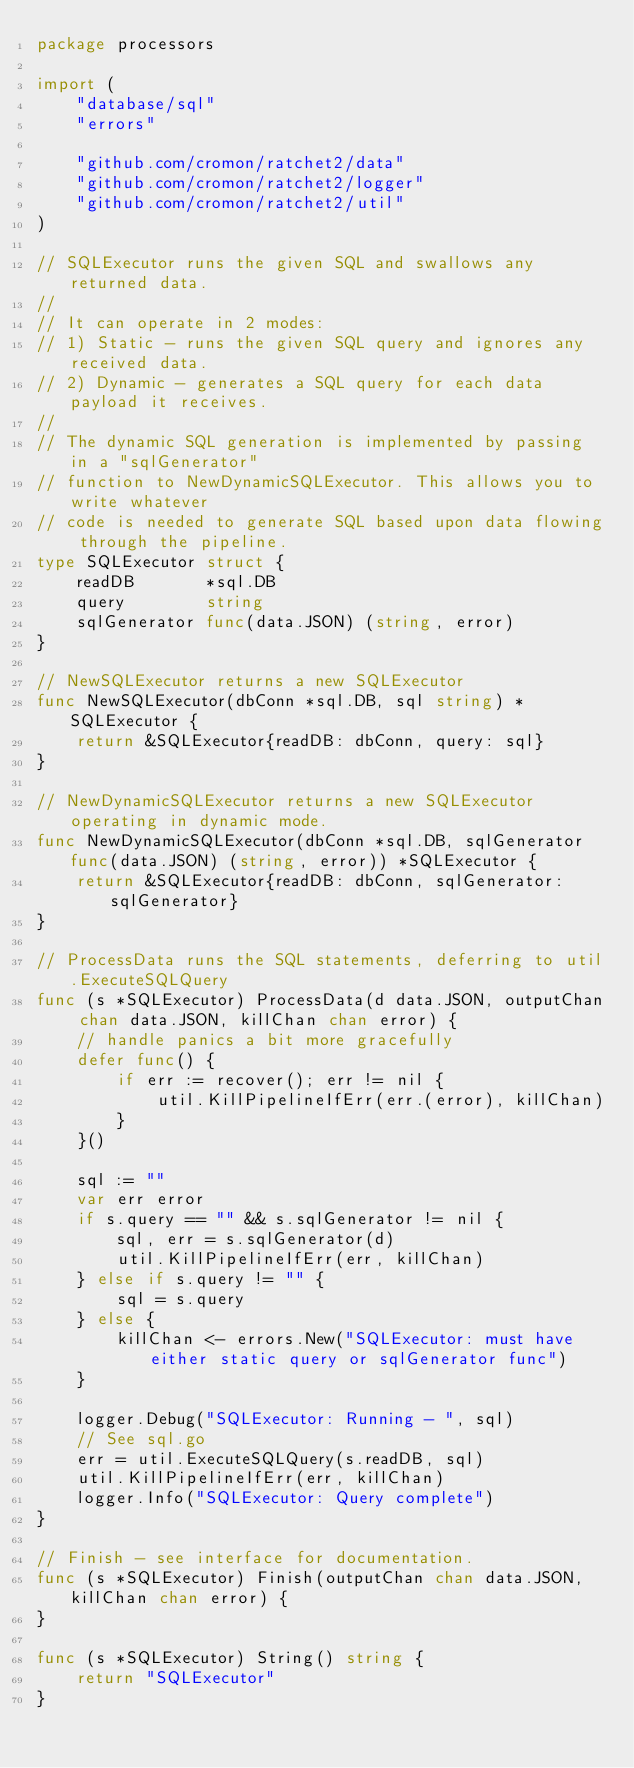Convert code to text. <code><loc_0><loc_0><loc_500><loc_500><_Go_>package processors

import (
	"database/sql"
	"errors"

	"github.com/cromon/ratchet2/data"
	"github.com/cromon/ratchet2/logger"
	"github.com/cromon/ratchet2/util"
)

// SQLExecutor runs the given SQL and swallows any returned data.
//
// It can operate in 2 modes:
// 1) Static - runs the given SQL query and ignores any received data.
// 2) Dynamic - generates a SQL query for each data payload it receives.
//
// The dynamic SQL generation is implemented by passing in a "sqlGenerator"
// function to NewDynamicSQLExecutor. This allows you to write whatever
// code is needed to generate SQL based upon data flowing through the pipeline.
type SQLExecutor struct {
	readDB       *sql.DB
	query        string
	sqlGenerator func(data.JSON) (string, error)
}

// NewSQLExecutor returns a new SQLExecutor
func NewSQLExecutor(dbConn *sql.DB, sql string) *SQLExecutor {
	return &SQLExecutor{readDB: dbConn, query: sql}
}

// NewDynamicSQLExecutor returns a new SQLExecutor operating in dynamic mode.
func NewDynamicSQLExecutor(dbConn *sql.DB, sqlGenerator func(data.JSON) (string, error)) *SQLExecutor {
	return &SQLExecutor{readDB: dbConn, sqlGenerator: sqlGenerator}
}

// ProcessData runs the SQL statements, deferring to util.ExecuteSQLQuery
func (s *SQLExecutor) ProcessData(d data.JSON, outputChan chan data.JSON, killChan chan error) {
	// handle panics a bit more gracefully
	defer func() {
		if err := recover(); err != nil {
			util.KillPipelineIfErr(err.(error), killChan)
		}
	}()

	sql := ""
	var err error
	if s.query == "" && s.sqlGenerator != nil {
		sql, err = s.sqlGenerator(d)
		util.KillPipelineIfErr(err, killChan)
	} else if s.query != "" {
		sql = s.query
	} else {
		killChan <- errors.New("SQLExecutor: must have either static query or sqlGenerator func")
	}

	logger.Debug("SQLExecutor: Running - ", sql)
	// See sql.go
	err = util.ExecuteSQLQuery(s.readDB, sql)
	util.KillPipelineIfErr(err, killChan)
	logger.Info("SQLExecutor: Query complete")
}

// Finish - see interface for documentation.
func (s *SQLExecutor) Finish(outputChan chan data.JSON, killChan chan error) {
}

func (s *SQLExecutor) String() string {
	return "SQLExecutor"
}
</code> 